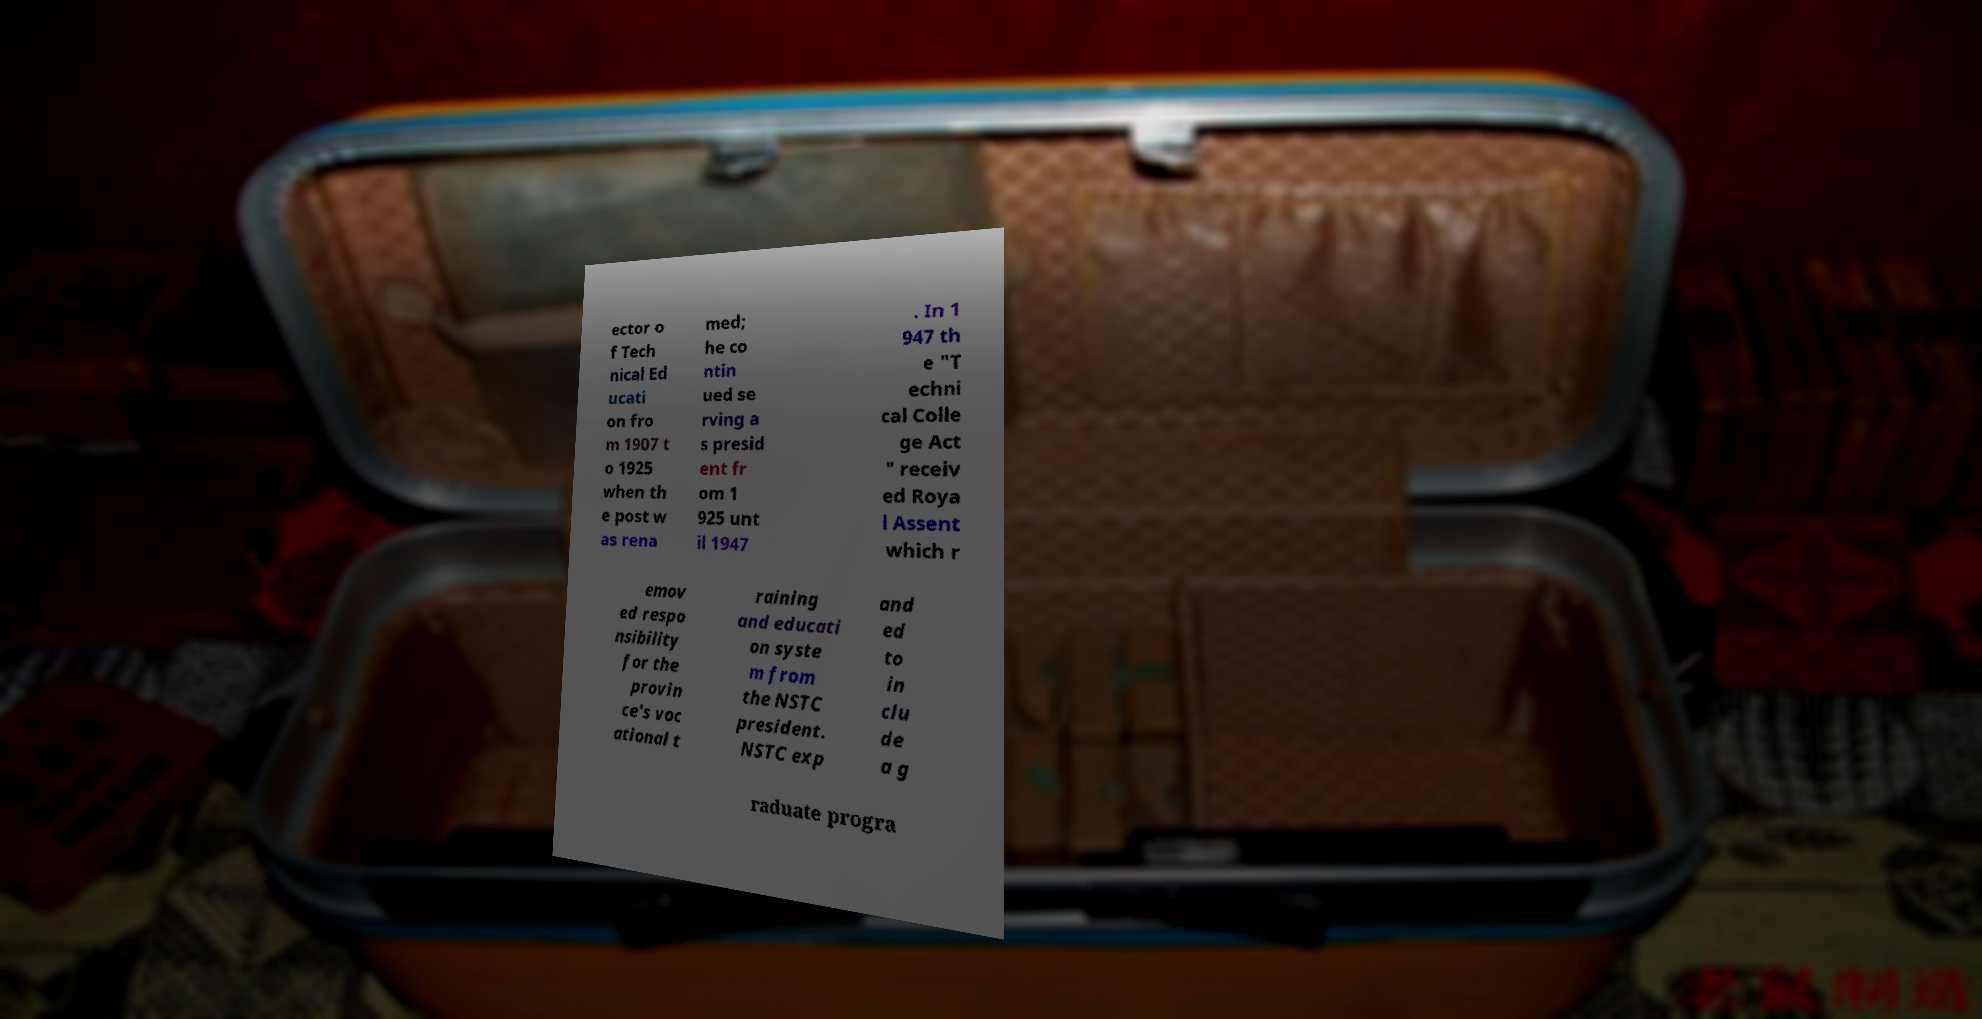Please read and relay the text visible in this image. What does it say? ector o f Tech nical Ed ucati on fro m 1907 t o 1925 when th e post w as rena med; he co ntin ued se rving a s presid ent fr om 1 925 unt il 1947 . In 1 947 th e "T echni cal Colle ge Act " receiv ed Roya l Assent which r emov ed respo nsibility for the provin ce's voc ational t raining and educati on syste m from the NSTC president. NSTC exp and ed to in clu de a g raduate progra 